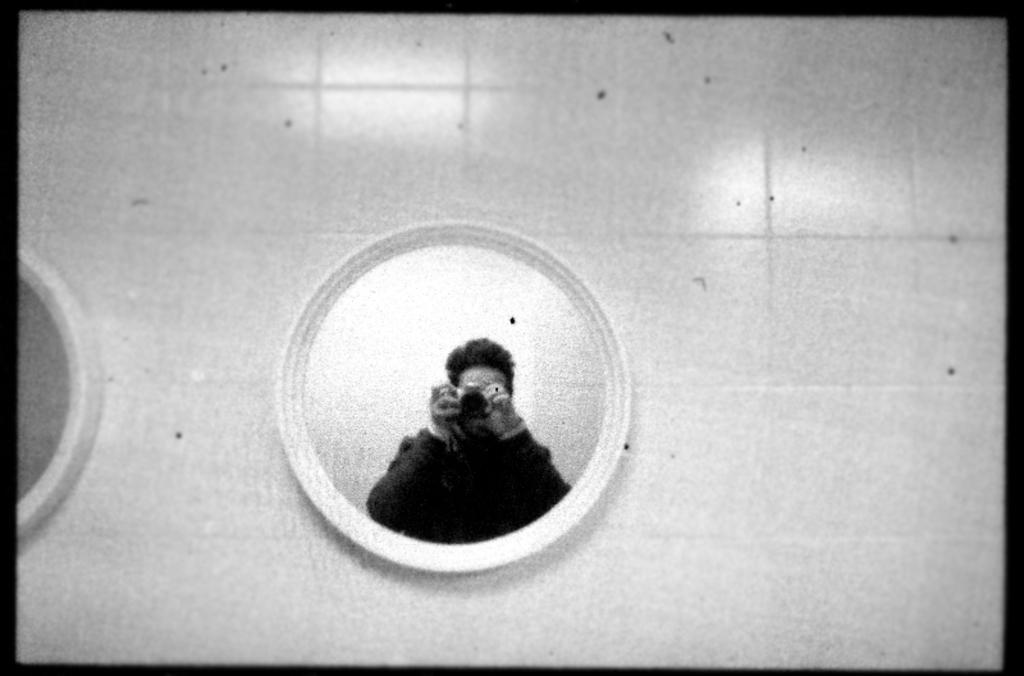Please provide a concise description of this image. As we can see in the image there are white color tiles and mirrors. In mirror there is reflection of a man wearing black color jacket and holding camera. 